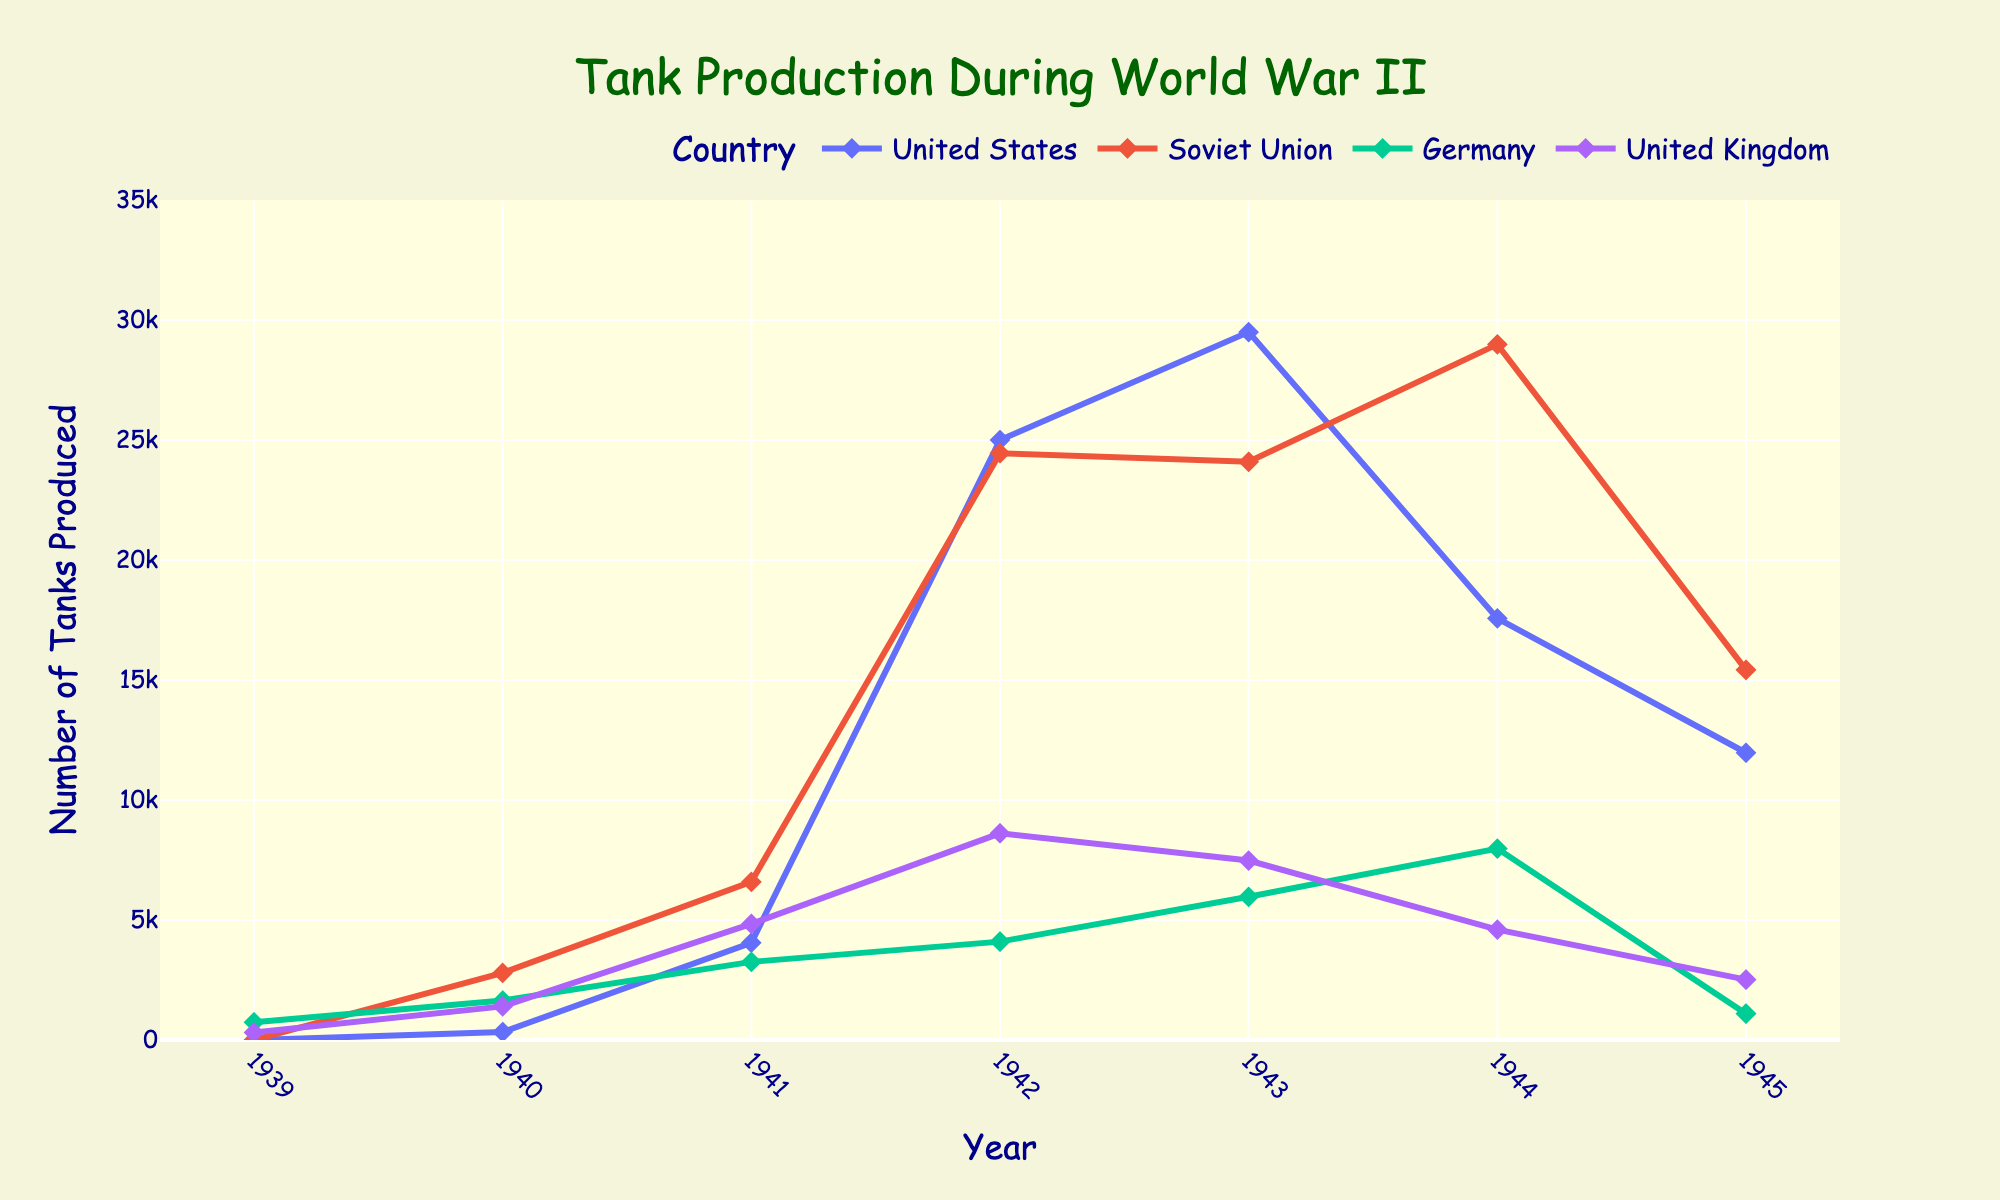What was the highest number of tanks produced by the Soviet Union in any given year during the war? Observe the highest peak in the Soviet Union's line on the chart, which occurs in 1944 with 28,983 tanks produced.
Answer: 28,983 Which year saw the highest tank production for the United Kingdom? Identify the peak year for the United Kingdom's line, which occurs in 1942 with 8,611 tanks produced.
Answer: 1942 Compare the tank production of Germany and the United States in 1942. Which country produced more tanks, and by how much? In 1942, compare the heights of the points for Germany (4,098 tanks) and the United States (24,997 tanks). The United States produced 24,997 - 4,098 = 20,899 more tanks than Germany.
Answer: The United States produced 20,899 more tanks Which country had the largest decrease in tank production from 1944 to 1945? Look at the differences in tank production between 1944 and 1945 for each country: the United States from 17,565 to 11,968, the Soviet Union from 28,983 to 15,422, Germany from 7,975 to 1,098, and the United Kingdom from 4,600 to 2,515. The Soviet Union had the largest decrease of 28,983 - 15,422 = 13,561 tanks.
Answer: Soviet Union In what year did Germany produce the most tanks, and how many tanks were produced? Germany's highest production peak on the chart is in 1944 with 7,975 tanks.
Answer: 1944 with 7,975 tanks By how much did Soviet tank production exceed German tank production in 1943? Compare Soviet production (24,092 tanks) to German production (5,966 tanks) in 1943. The difference is 24,092 - 5,966 = 18,126 tanks.
Answer: 18,126 tanks Which year had the most balanced tank production among the four countries? Consider the year where differences in production values are minimized. In 1940, production values are more balanced: United States (331 tanks), Soviet Union (2,794 tanks), Germany (1,643 tanks), and United Kingdom (1,399 tanks), showing smaller differences compared to other years.
Answer: 1940 From 1942 to 1943, did any country's tank production decrease? If so, which one? Observe the trends between 1942 and 1943: The Soviet Union's production slightly decreased from 24,446 tanks to 24,092 tanks.
Answer: Soviet Union What is the combined tank production of all four countries in 1945? Sum the tank production for all countries in 1945: United States (11,968), Soviet Union (15,422), Germany (1,098), United Kingdom (2,515). Total is 11,968 + 15,422 + 1,098 + 2,515 = 30,003 tanks.
Answer: 30,003 